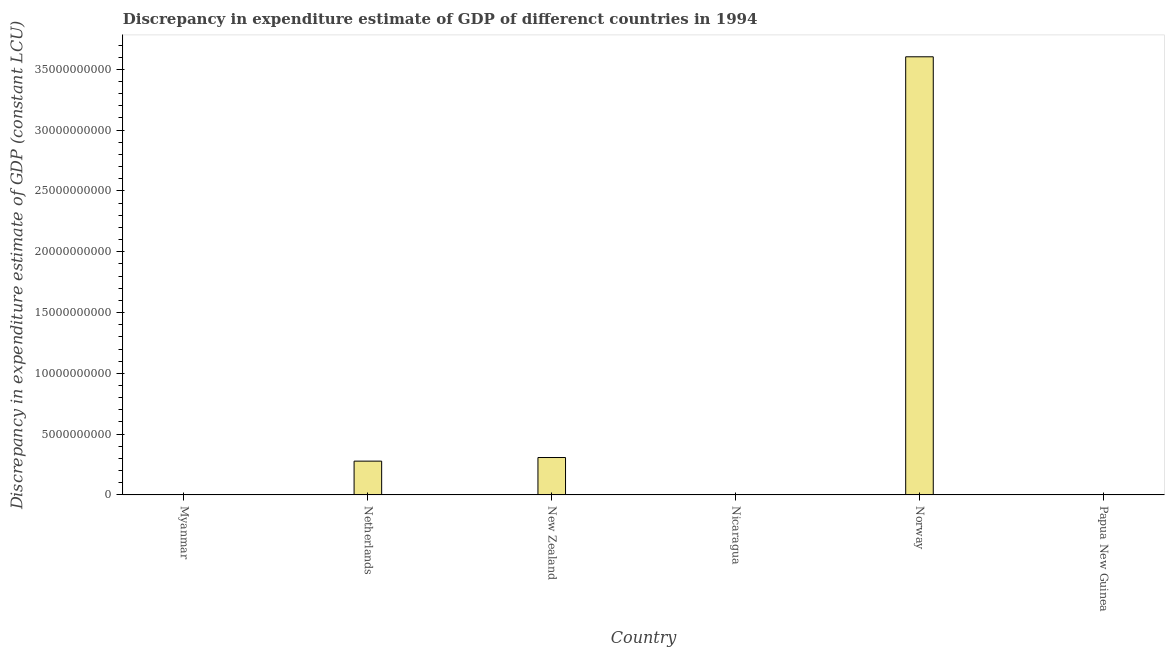Does the graph contain any zero values?
Ensure brevity in your answer.  Yes. What is the title of the graph?
Your answer should be compact. Discrepancy in expenditure estimate of GDP of differenct countries in 1994. What is the label or title of the Y-axis?
Make the answer very short. Discrepancy in expenditure estimate of GDP (constant LCU). What is the discrepancy in expenditure estimate of gdp in Netherlands?
Keep it short and to the point. 2.78e+09. Across all countries, what is the maximum discrepancy in expenditure estimate of gdp?
Your answer should be compact. 3.60e+1. Across all countries, what is the minimum discrepancy in expenditure estimate of gdp?
Offer a very short reply. 0. In which country was the discrepancy in expenditure estimate of gdp maximum?
Offer a terse response. Norway. What is the sum of the discrepancy in expenditure estimate of gdp?
Provide a short and direct response. 4.19e+1. What is the difference between the discrepancy in expenditure estimate of gdp in New Zealand and Norway?
Provide a succinct answer. -3.30e+1. What is the average discrepancy in expenditure estimate of gdp per country?
Your answer should be very brief. 6.98e+09. What is the median discrepancy in expenditure estimate of gdp?
Provide a succinct answer. 1.39e+09. In how many countries, is the discrepancy in expenditure estimate of gdp greater than 18000000000 LCU?
Your answer should be very brief. 1. What is the difference between the highest and the second highest discrepancy in expenditure estimate of gdp?
Offer a terse response. 3.30e+1. Is the sum of the discrepancy in expenditure estimate of gdp in Netherlands and New Zealand greater than the maximum discrepancy in expenditure estimate of gdp across all countries?
Offer a terse response. No. What is the difference between the highest and the lowest discrepancy in expenditure estimate of gdp?
Make the answer very short. 3.60e+1. In how many countries, is the discrepancy in expenditure estimate of gdp greater than the average discrepancy in expenditure estimate of gdp taken over all countries?
Provide a short and direct response. 1. How many countries are there in the graph?
Offer a very short reply. 6. What is the difference between two consecutive major ticks on the Y-axis?
Keep it short and to the point. 5.00e+09. Are the values on the major ticks of Y-axis written in scientific E-notation?
Offer a terse response. No. What is the Discrepancy in expenditure estimate of GDP (constant LCU) of Myanmar?
Make the answer very short. 0. What is the Discrepancy in expenditure estimate of GDP (constant LCU) in Netherlands?
Make the answer very short. 2.78e+09. What is the Discrepancy in expenditure estimate of GDP (constant LCU) in New Zealand?
Keep it short and to the point. 3.08e+09. What is the Discrepancy in expenditure estimate of GDP (constant LCU) of Norway?
Give a very brief answer. 3.60e+1. What is the Discrepancy in expenditure estimate of GDP (constant LCU) of Papua New Guinea?
Make the answer very short. 0. What is the difference between the Discrepancy in expenditure estimate of GDP (constant LCU) in Netherlands and New Zealand?
Ensure brevity in your answer.  -2.97e+08. What is the difference between the Discrepancy in expenditure estimate of GDP (constant LCU) in Netherlands and Norway?
Make the answer very short. -3.33e+1. What is the difference between the Discrepancy in expenditure estimate of GDP (constant LCU) in New Zealand and Norway?
Provide a short and direct response. -3.30e+1. What is the ratio of the Discrepancy in expenditure estimate of GDP (constant LCU) in Netherlands to that in New Zealand?
Offer a very short reply. 0.9. What is the ratio of the Discrepancy in expenditure estimate of GDP (constant LCU) in Netherlands to that in Norway?
Give a very brief answer. 0.08. What is the ratio of the Discrepancy in expenditure estimate of GDP (constant LCU) in New Zealand to that in Norway?
Provide a short and direct response. 0.09. 